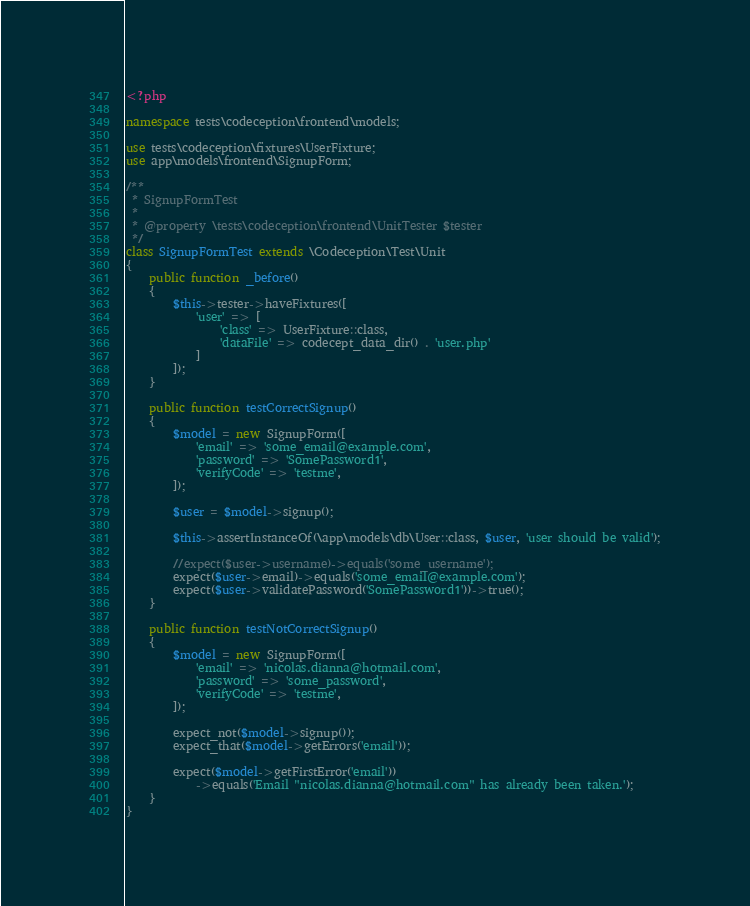<code> <loc_0><loc_0><loc_500><loc_500><_PHP_><?php

namespace tests\codeception\frontend\models;

use tests\codeception\fixtures\UserFixture;
use app\models\frontend\SignupForm;

/**
 * SignupFormTest
 *
 * @property \tests\codeception\frontend\UnitTester $tester
 */
class SignupFormTest extends \Codeception\Test\Unit
{
    public function _before()
    {
        $this->tester->haveFixtures([
            'user' => [
                'class' => UserFixture::class,
                'dataFile' => codecept_data_dir() . 'user.php'
            ]
        ]);
    }

    public function testCorrectSignup()
    {
        $model = new SignupForm([
            'email' => 'some_email@example.com',
            'password' => 'SomePassword1',
            'verifyCode' => 'testme',
        ]);

        $user = $model->signup();

        $this->assertInstanceOf(\app\models\db\User::class, $user, 'user should be valid');

        //expect($user->username)->equals('some_username');
        expect($user->email)->equals('some_email@example.com');
        expect($user->validatePassword('SomePassword1'))->true();
    }

    public function testNotCorrectSignup()
    {
        $model = new SignupForm([
            'email' => 'nicolas.dianna@hotmail.com',
            'password' => 'some_password',
            'verifyCode' => 'testme',
        ]);

        expect_not($model->signup());
        expect_that($model->getErrors('email'));

        expect($model->getFirstError('email'))
            ->equals('Email "nicolas.dianna@hotmail.com" has already been taken.');
    }
}</code> 